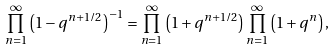Convert formula to latex. <formula><loc_0><loc_0><loc_500><loc_500>\prod _ { n = 1 } ^ { \infty } \left ( 1 - q ^ { n + 1 / 2 } \right ) ^ { - 1 } = \prod _ { n = 1 } ^ { \infty } \left ( 1 + q ^ { n + 1 / 2 } \right ) \prod _ { n = 1 } ^ { \infty } \left ( 1 + q ^ { n } \right ) ,</formula> 